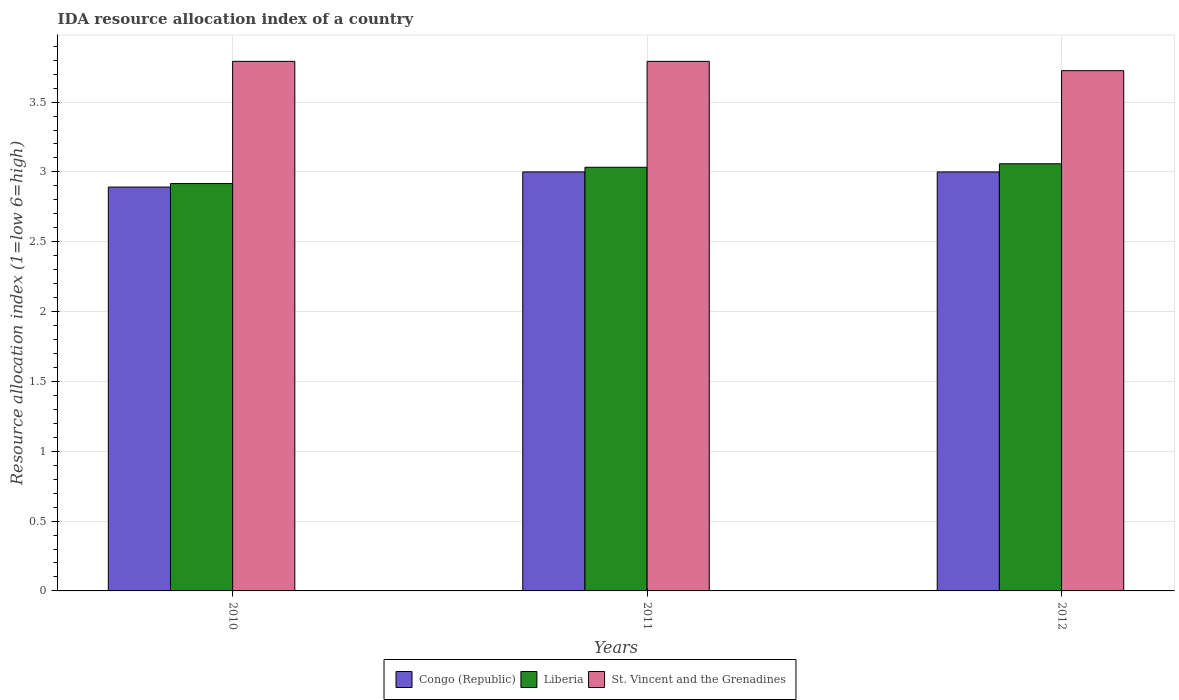Are the number of bars per tick equal to the number of legend labels?
Your response must be concise. Yes. Are the number of bars on each tick of the X-axis equal?
Your answer should be compact. Yes. What is the label of the 3rd group of bars from the left?
Your response must be concise. 2012. In how many cases, is the number of bars for a given year not equal to the number of legend labels?
Make the answer very short. 0. What is the IDA resource allocation index in Liberia in 2012?
Make the answer very short. 3.06. Across all years, what is the maximum IDA resource allocation index in Liberia?
Provide a succinct answer. 3.06. Across all years, what is the minimum IDA resource allocation index in Liberia?
Offer a very short reply. 2.92. What is the total IDA resource allocation index in St. Vincent and the Grenadines in the graph?
Offer a very short reply. 11.31. What is the difference between the IDA resource allocation index in Liberia in 2011 and the IDA resource allocation index in Congo (Republic) in 2012?
Keep it short and to the point. 0.03. What is the average IDA resource allocation index in St. Vincent and the Grenadines per year?
Give a very brief answer. 3.77. In the year 2010, what is the difference between the IDA resource allocation index in Liberia and IDA resource allocation index in St. Vincent and the Grenadines?
Provide a succinct answer. -0.88. In how many years, is the IDA resource allocation index in St. Vincent and the Grenadines greater than 0.1?
Ensure brevity in your answer.  3. What is the ratio of the IDA resource allocation index in Liberia in 2010 to that in 2012?
Your response must be concise. 0.95. Is the IDA resource allocation index in Liberia in 2010 less than that in 2011?
Provide a short and direct response. Yes. What is the difference between the highest and the lowest IDA resource allocation index in Liberia?
Offer a terse response. 0.14. Is the sum of the IDA resource allocation index in St. Vincent and the Grenadines in 2011 and 2012 greater than the maximum IDA resource allocation index in Liberia across all years?
Your answer should be compact. Yes. What does the 1st bar from the left in 2012 represents?
Make the answer very short. Congo (Republic). What does the 2nd bar from the right in 2011 represents?
Make the answer very short. Liberia. Are all the bars in the graph horizontal?
Your answer should be very brief. No. Where does the legend appear in the graph?
Your response must be concise. Bottom center. What is the title of the graph?
Offer a terse response. IDA resource allocation index of a country. Does "East Asia (all income levels)" appear as one of the legend labels in the graph?
Offer a very short reply. No. What is the label or title of the X-axis?
Ensure brevity in your answer.  Years. What is the label or title of the Y-axis?
Your response must be concise. Resource allocation index (1=low 6=high). What is the Resource allocation index (1=low 6=high) of Congo (Republic) in 2010?
Make the answer very short. 2.89. What is the Resource allocation index (1=low 6=high) in Liberia in 2010?
Keep it short and to the point. 2.92. What is the Resource allocation index (1=low 6=high) of St. Vincent and the Grenadines in 2010?
Make the answer very short. 3.79. What is the Resource allocation index (1=low 6=high) in Congo (Republic) in 2011?
Offer a terse response. 3. What is the Resource allocation index (1=low 6=high) in Liberia in 2011?
Your response must be concise. 3.03. What is the Resource allocation index (1=low 6=high) of St. Vincent and the Grenadines in 2011?
Keep it short and to the point. 3.79. What is the Resource allocation index (1=low 6=high) in Liberia in 2012?
Ensure brevity in your answer.  3.06. What is the Resource allocation index (1=low 6=high) in St. Vincent and the Grenadines in 2012?
Keep it short and to the point. 3.73. Across all years, what is the maximum Resource allocation index (1=low 6=high) in Congo (Republic)?
Keep it short and to the point. 3. Across all years, what is the maximum Resource allocation index (1=low 6=high) in Liberia?
Offer a very short reply. 3.06. Across all years, what is the maximum Resource allocation index (1=low 6=high) of St. Vincent and the Grenadines?
Make the answer very short. 3.79. Across all years, what is the minimum Resource allocation index (1=low 6=high) in Congo (Republic)?
Give a very brief answer. 2.89. Across all years, what is the minimum Resource allocation index (1=low 6=high) in Liberia?
Your response must be concise. 2.92. Across all years, what is the minimum Resource allocation index (1=low 6=high) of St. Vincent and the Grenadines?
Make the answer very short. 3.73. What is the total Resource allocation index (1=low 6=high) in Congo (Republic) in the graph?
Offer a very short reply. 8.89. What is the total Resource allocation index (1=low 6=high) of Liberia in the graph?
Provide a short and direct response. 9.01. What is the total Resource allocation index (1=low 6=high) of St. Vincent and the Grenadines in the graph?
Your answer should be compact. 11.31. What is the difference between the Resource allocation index (1=low 6=high) of Congo (Republic) in 2010 and that in 2011?
Offer a terse response. -0.11. What is the difference between the Resource allocation index (1=low 6=high) of Liberia in 2010 and that in 2011?
Give a very brief answer. -0.12. What is the difference between the Resource allocation index (1=low 6=high) in St. Vincent and the Grenadines in 2010 and that in 2011?
Your answer should be compact. 0. What is the difference between the Resource allocation index (1=low 6=high) of Congo (Republic) in 2010 and that in 2012?
Give a very brief answer. -0.11. What is the difference between the Resource allocation index (1=low 6=high) of Liberia in 2010 and that in 2012?
Your answer should be compact. -0.14. What is the difference between the Resource allocation index (1=low 6=high) of St. Vincent and the Grenadines in 2010 and that in 2012?
Your answer should be compact. 0.07. What is the difference between the Resource allocation index (1=low 6=high) in Liberia in 2011 and that in 2012?
Provide a succinct answer. -0.03. What is the difference between the Resource allocation index (1=low 6=high) in St. Vincent and the Grenadines in 2011 and that in 2012?
Provide a succinct answer. 0.07. What is the difference between the Resource allocation index (1=low 6=high) of Congo (Republic) in 2010 and the Resource allocation index (1=low 6=high) of Liberia in 2011?
Make the answer very short. -0.14. What is the difference between the Resource allocation index (1=low 6=high) of Liberia in 2010 and the Resource allocation index (1=low 6=high) of St. Vincent and the Grenadines in 2011?
Your response must be concise. -0.88. What is the difference between the Resource allocation index (1=low 6=high) of Congo (Republic) in 2010 and the Resource allocation index (1=low 6=high) of Liberia in 2012?
Keep it short and to the point. -0.17. What is the difference between the Resource allocation index (1=low 6=high) of Congo (Republic) in 2010 and the Resource allocation index (1=low 6=high) of St. Vincent and the Grenadines in 2012?
Provide a succinct answer. -0.83. What is the difference between the Resource allocation index (1=low 6=high) of Liberia in 2010 and the Resource allocation index (1=low 6=high) of St. Vincent and the Grenadines in 2012?
Make the answer very short. -0.81. What is the difference between the Resource allocation index (1=low 6=high) of Congo (Republic) in 2011 and the Resource allocation index (1=low 6=high) of Liberia in 2012?
Give a very brief answer. -0.06. What is the difference between the Resource allocation index (1=low 6=high) in Congo (Republic) in 2011 and the Resource allocation index (1=low 6=high) in St. Vincent and the Grenadines in 2012?
Offer a very short reply. -0.72. What is the difference between the Resource allocation index (1=low 6=high) in Liberia in 2011 and the Resource allocation index (1=low 6=high) in St. Vincent and the Grenadines in 2012?
Provide a succinct answer. -0.69. What is the average Resource allocation index (1=low 6=high) in Congo (Republic) per year?
Provide a short and direct response. 2.96. What is the average Resource allocation index (1=low 6=high) in Liberia per year?
Make the answer very short. 3. What is the average Resource allocation index (1=low 6=high) in St. Vincent and the Grenadines per year?
Provide a succinct answer. 3.77. In the year 2010, what is the difference between the Resource allocation index (1=low 6=high) of Congo (Republic) and Resource allocation index (1=low 6=high) of Liberia?
Your response must be concise. -0.03. In the year 2010, what is the difference between the Resource allocation index (1=low 6=high) of Congo (Republic) and Resource allocation index (1=low 6=high) of St. Vincent and the Grenadines?
Offer a terse response. -0.9. In the year 2010, what is the difference between the Resource allocation index (1=low 6=high) in Liberia and Resource allocation index (1=low 6=high) in St. Vincent and the Grenadines?
Keep it short and to the point. -0.88. In the year 2011, what is the difference between the Resource allocation index (1=low 6=high) of Congo (Republic) and Resource allocation index (1=low 6=high) of Liberia?
Keep it short and to the point. -0.03. In the year 2011, what is the difference between the Resource allocation index (1=low 6=high) of Congo (Republic) and Resource allocation index (1=low 6=high) of St. Vincent and the Grenadines?
Your answer should be compact. -0.79. In the year 2011, what is the difference between the Resource allocation index (1=low 6=high) of Liberia and Resource allocation index (1=low 6=high) of St. Vincent and the Grenadines?
Make the answer very short. -0.76. In the year 2012, what is the difference between the Resource allocation index (1=low 6=high) of Congo (Republic) and Resource allocation index (1=low 6=high) of Liberia?
Your response must be concise. -0.06. In the year 2012, what is the difference between the Resource allocation index (1=low 6=high) of Congo (Republic) and Resource allocation index (1=low 6=high) of St. Vincent and the Grenadines?
Ensure brevity in your answer.  -0.72. What is the ratio of the Resource allocation index (1=low 6=high) of Congo (Republic) in 2010 to that in 2011?
Provide a short and direct response. 0.96. What is the ratio of the Resource allocation index (1=low 6=high) of Liberia in 2010 to that in 2011?
Provide a short and direct response. 0.96. What is the ratio of the Resource allocation index (1=low 6=high) in St. Vincent and the Grenadines in 2010 to that in 2011?
Make the answer very short. 1. What is the ratio of the Resource allocation index (1=low 6=high) in Congo (Republic) in 2010 to that in 2012?
Your answer should be compact. 0.96. What is the ratio of the Resource allocation index (1=low 6=high) of Liberia in 2010 to that in 2012?
Make the answer very short. 0.95. What is the ratio of the Resource allocation index (1=low 6=high) in St. Vincent and the Grenadines in 2010 to that in 2012?
Provide a short and direct response. 1.02. What is the ratio of the Resource allocation index (1=low 6=high) in St. Vincent and the Grenadines in 2011 to that in 2012?
Offer a very short reply. 1.02. What is the difference between the highest and the second highest Resource allocation index (1=low 6=high) in Liberia?
Provide a short and direct response. 0.03. What is the difference between the highest and the second highest Resource allocation index (1=low 6=high) in St. Vincent and the Grenadines?
Ensure brevity in your answer.  0. What is the difference between the highest and the lowest Resource allocation index (1=low 6=high) of Congo (Republic)?
Offer a very short reply. 0.11. What is the difference between the highest and the lowest Resource allocation index (1=low 6=high) of Liberia?
Make the answer very short. 0.14. What is the difference between the highest and the lowest Resource allocation index (1=low 6=high) in St. Vincent and the Grenadines?
Keep it short and to the point. 0.07. 